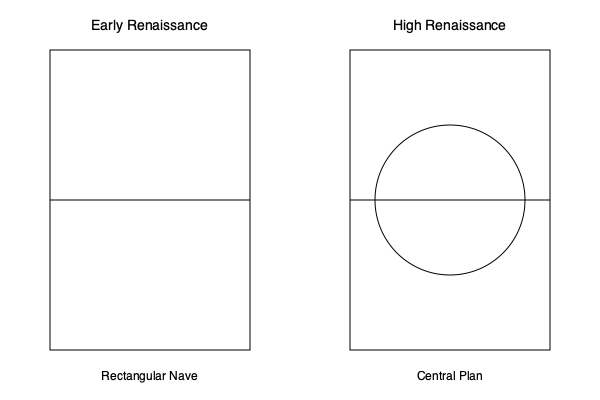Analyze the architectural evolution from Early Renaissance to High Renaissance churches as depicted in the floor plan diagrams. What significant change in spatial organization is evident, and how does this reflect the philosophical and aesthetic shifts of the period? 1. Early Renaissance Church Plan:
   - Rectangular shape, typical of basilica-style churches
   - Linear arrangement with a clear longitudinal axis
   - Reflects medieval traditions and early humanist ideas

2. High Renaissance Church Plan:
   - Introduction of a central plan with a circular element
   - Combines rectangular and circular forms
   - Represents a shift towards geometric perfection and harmony

3. Philosophical and Aesthetic Shifts:
   - Early Renaissance: Focus on linear perspective and rational order
   - High Renaissance: Emphasis on ideal proportions and divine perfection

4. Spatial Organization Changes:
   - From linear progression to centralized focus
   - Shift from directional space to radial symmetry
   - Reflects Neo-Platonic ideas of the circle as a perfect form

5. Symbolic Implications:
   - Early plan: Journey towards salvation (linear path)
   - High Renaissance plan: Unity of man and cosmos (centralized plan)

6. Architectural Influences:
   - Early plan influenced by Roman basilicas
   - High Renaissance plan inspired by classical temples and Vitruvian ideals

7. Examples:
   - Early Renaissance: Santa Maria Novella, Florence
   - High Renaissance: Tempietto di San Pietro in Montorio, Rome

This evolution demonstrates a move from the rational, human-scaled architecture of the Early Renaissance to the idealized, cosmic-oriented designs of the High Renaissance, reflecting broader cultural and philosophical changes of the period.
Answer: Shift from linear to centralized plan, reflecting Renaissance ideals of perfection and cosmic harmony. 